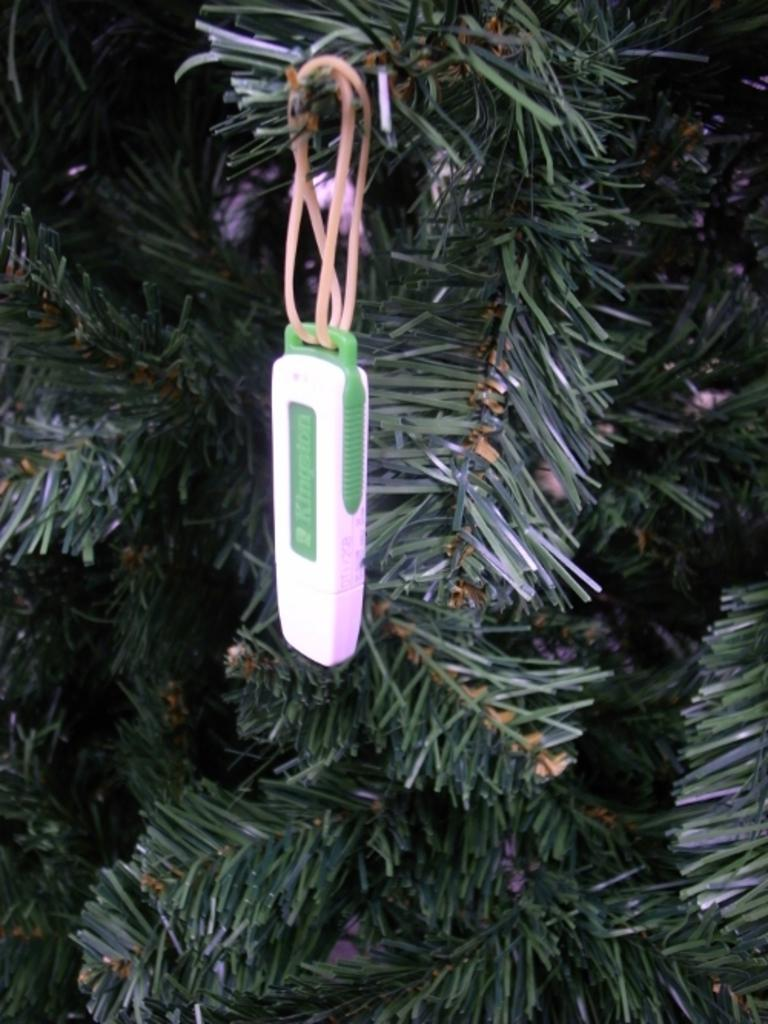What electronic device is present in the image? There is a pen drive in the image. How is the pen drive attached to the tree? The pen drive is tied to a tree using a thread. What type of material is used to secure the pen drive to the tree? A thread is used to tie the pen drive to the tree. What type of shop can be seen in the image? There is no shop present in the image; it features a pen drive tied to a tree with a thread. How does the pen drive improve the memory of the person who tied it to the tree? The pen drive does not improve memory; it is an electronic storage device. 